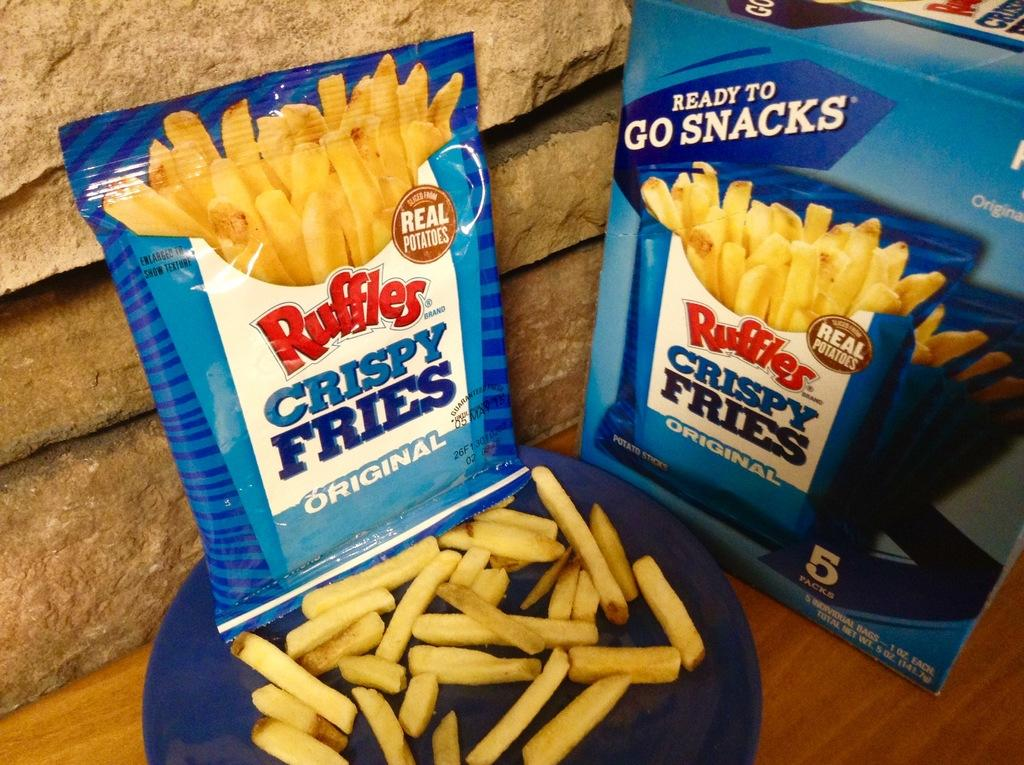What type of food is in the packet visible in the image? There is a packet of french fries in the image. What other item related to the french fries can be seen in the image? There is a plate filled with french fries in the image. Where are the items located in the image? The items are on a table. What can be seen in the background of the image? There is a wall visible in the background of the image. Can you describe the possible setting of the image? The image may have been taken in a hall. What type of milk is being served in the image? There is no milk present in the image. Can you describe the jewel that is being displayed on the table? There is no jewel present in the image. 